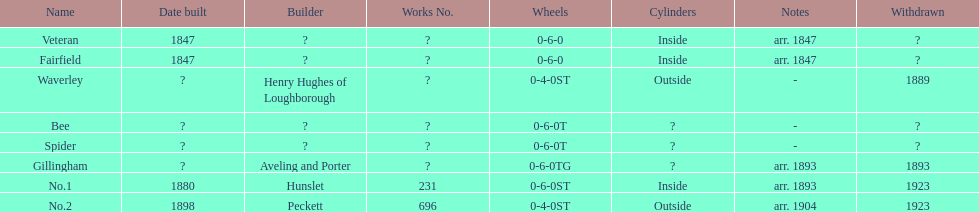Were there more with indoor or outdoor cylinders? Inside. Write the full table. {'header': ['Name', 'Date built', 'Builder', 'Works No.', 'Wheels', 'Cylinders', 'Notes', 'Withdrawn'], 'rows': [['Veteran', '1847', '?', '?', '0-6-0', 'Inside', 'arr. 1847', '?'], ['Fairfield', '1847', '?', '?', '0-6-0', 'Inside', 'arr. 1847', '?'], ['Waverley', '?', 'Henry Hughes of Loughborough', '?', '0-4-0ST', 'Outside', '-', '1889'], ['Bee', '?', '?', '?', '0-6-0T', '?', '-', '?'], ['Spider', '?', '?', '?', '0-6-0T', '?', '-', '?'], ['Gillingham', '?', 'Aveling and Porter', '?', '0-6-0TG', '?', 'arr. 1893', '1893'], ['No.1', '1880', 'Hunslet', '231', '0-6-0ST', 'Inside', 'arr. 1893', '1923'], ['No.2', '1898', 'Peckett', '696', '0-4-0ST', 'Outside', 'arr. 1904', '1923']]} 